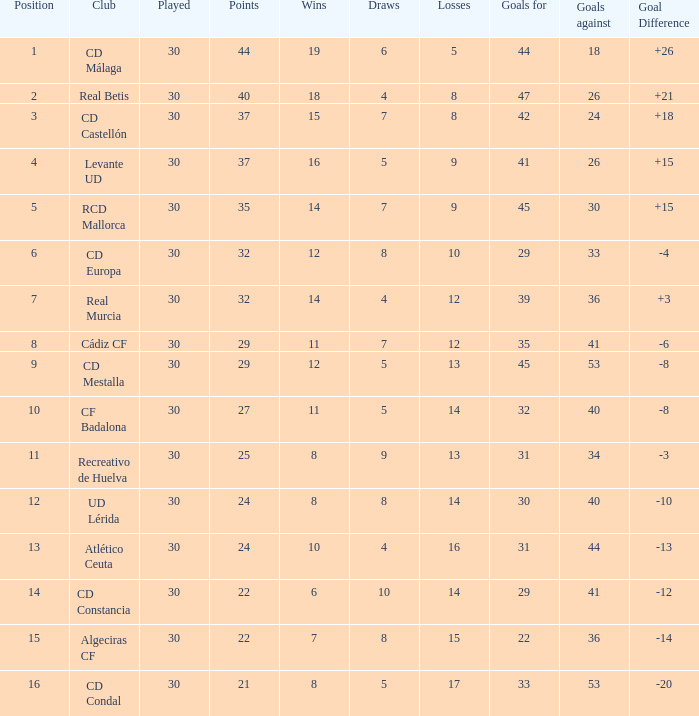What are the objectives for when performed is greater than 30? None. 